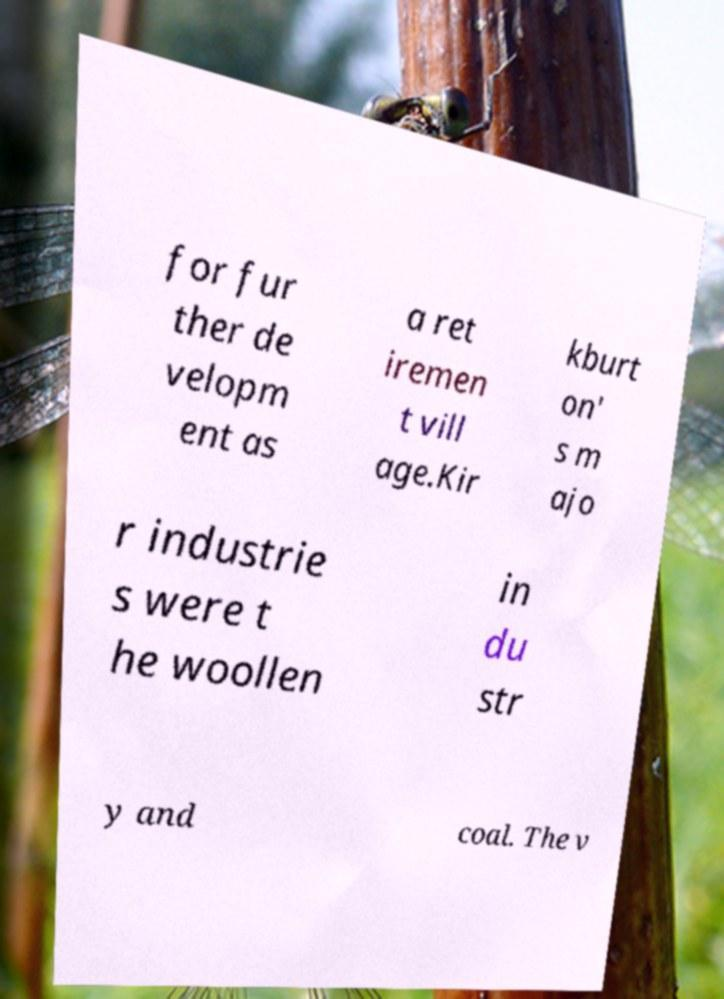Can you read and provide the text displayed in the image?This photo seems to have some interesting text. Can you extract and type it out for me? for fur ther de velopm ent as a ret iremen t vill age.Kir kburt on' s m ajo r industrie s were t he woollen in du str y and coal. The v 